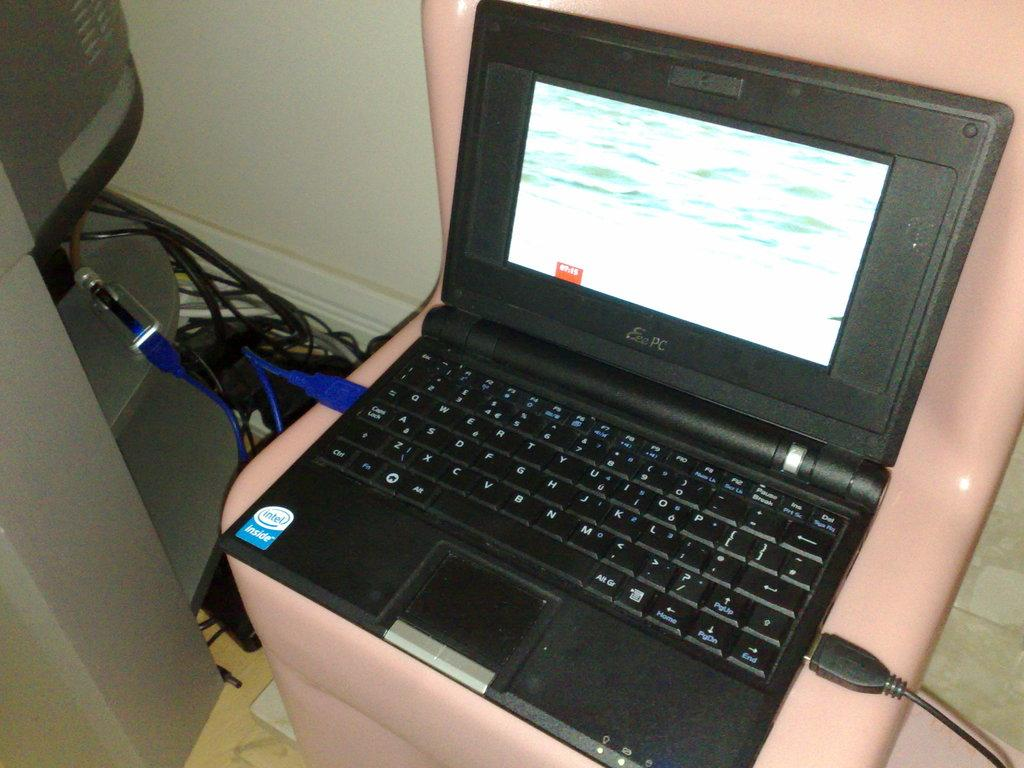<image>
Share a concise interpretation of the image provided. Dark PC laptop with a blue and white Intel Inside sticker on it. 